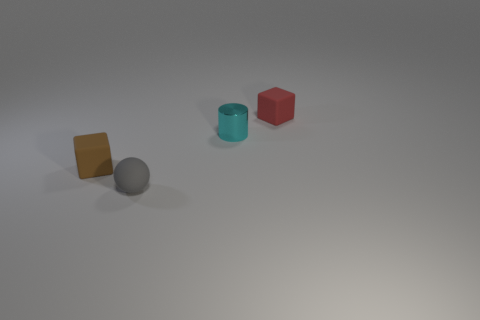Is the number of small blue balls greater than the number of brown things?
Give a very brief answer. No. Is the material of the red block the same as the tiny brown block?
Your answer should be compact. Yes. Is there anything else that is made of the same material as the small cylinder?
Provide a succinct answer. No. Are there more cyan metal cylinders that are in front of the tiny cyan metal object than blue rubber cubes?
Keep it short and to the point. No. Is the color of the cylinder the same as the tiny ball?
Make the answer very short. No. How many other small things have the same shape as the brown matte object?
Keep it short and to the point. 1. There is a gray thing that is the same material as the red cube; what is its size?
Your answer should be compact. Small. There is a small object that is both behind the tiny ball and in front of the tiny cyan cylinder; what color is it?
Your answer should be very brief. Brown. How many blue things are the same size as the red block?
Keep it short and to the point. 0. There is a thing that is behind the tiny ball and in front of the small metallic thing; what is its size?
Ensure brevity in your answer.  Small. 